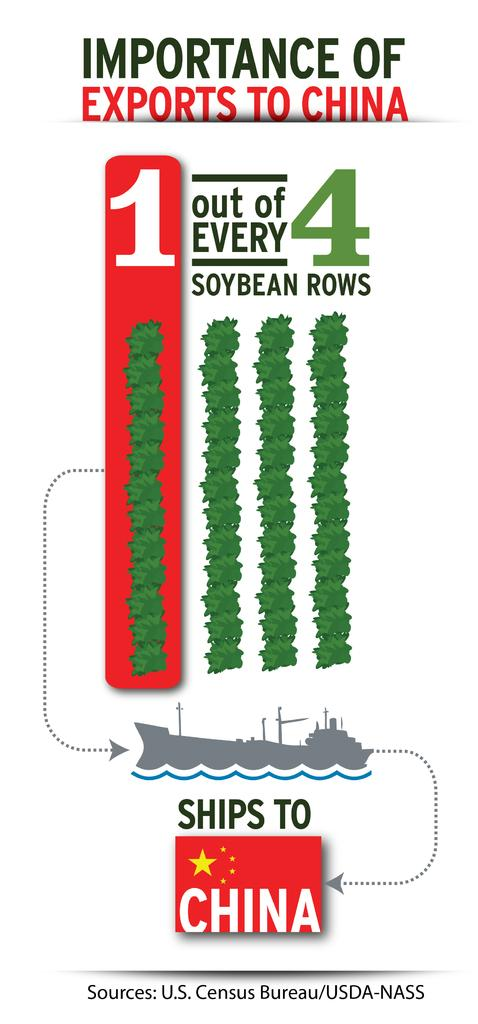<image>
Describe the image concisely. The image from the U.S. Census Bureau is about the importance of exports to China. 